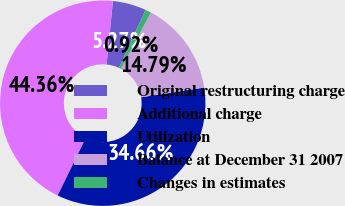<chart> <loc_0><loc_0><loc_500><loc_500><pie_chart><fcel>Original restructuring charge<fcel>Additional charge<fcel>Utilization<fcel>Balance at December 31 2007<fcel>Changes in estimates<nl><fcel>5.27%<fcel>44.36%<fcel>34.66%<fcel>14.79%<fcel>0.92%<nl></chart> 